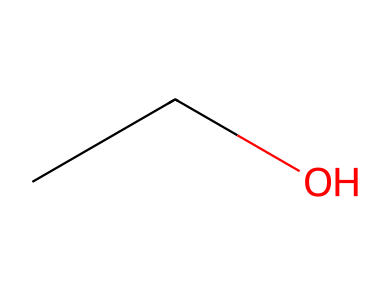What is the molecular formula of this chemical? The SMILES representation "CCO" indicates that there are two carbon (C) atoms, six hydrogen (H) atoms, and one oxygen (O) atom in the structure. These atoms combine to form the molecular formula C2H6O.
Answer: C2H6O How many carbon atoms are in this chemical? In the provided SMILES, "CCO", the two 'C' letters represent two carbon atoms in the structure.
Answer: 2 What type of functional group is present in this chemical? The presence of the "O" (oxygen) at the end of the SMILES "CCO" indicates that there is a hydroxyl (-OH) functional group present, which classifies it as an alcohol.
Answer: alcohol Does this chemical have any double bonds? In the SMILES "CCO", there are only single bonds between the two carbon atoms and between the last carbon and the oxygen atom. Therefore, there are no double bonds present in this chemical.
Answer: no What is a common use of this chemical in healthcare? The molecule represented by "CCO" is ethanol, which is commonly used as an antimicrobial agent in hand sanitizers and disinfectants in healthcare settings.
Answer: ethanol How many hydrogen atoms are bonded to each carbon atom? The first carbon (end carbon in "CCO") is bonded to three hydrogen atoms, while the second carbon (the other carbon) is bonded to two hydrogen atoms, resulting in a total of five hydrogen atoms across both carbons.
Answer: 3 and 2 